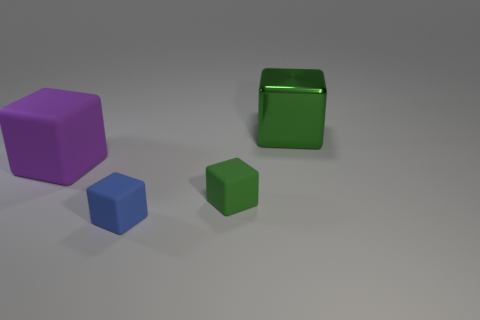What shape is the matte object that is the same color as the metal cube?
Provide a short and direct response. Cube. There is a block that is both to the right of the tiny blue cube and in front of the large rubber thing; what is its material?
Give a very brief answer. Rubber. Are there fewer large purple metallic spheres than metal things?
Ensure brevity in your answer.  Yes. There is a blue thing; is it the same shape as the small rubber thing behind the blue thing?
Give a very brief answer. Yes. There is a green matte object in front of the green metallic cube; does it have the same size as the tiny blue object?
Keep it short and to the point. Yes. What is the shape of the purple matte thing that is the same size as the green shiny object?
Offer a very short reply. Cube. Is the shape of the small green thing the same as the metallic object?
Your answer should be compact. Yes. How many other tiny blue matte objects have the same shape as the small blue matte object?
Your answer should be very brief. 0. How many small blocks are in front of the green matte cube?
Your answer should be compact. 1. There is a small matte thing right of the blue matte object; does it have the same color as the big metal object?
Ensure brevity in your answer.  Yes. 